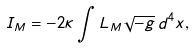<formula> <loc_0><loc_0><loc_500><loc_500>I _ { M } = - 2 \kappa \int L _ { M } \sqrt { - g } \, d ^ { 4 } x ,</formula> 